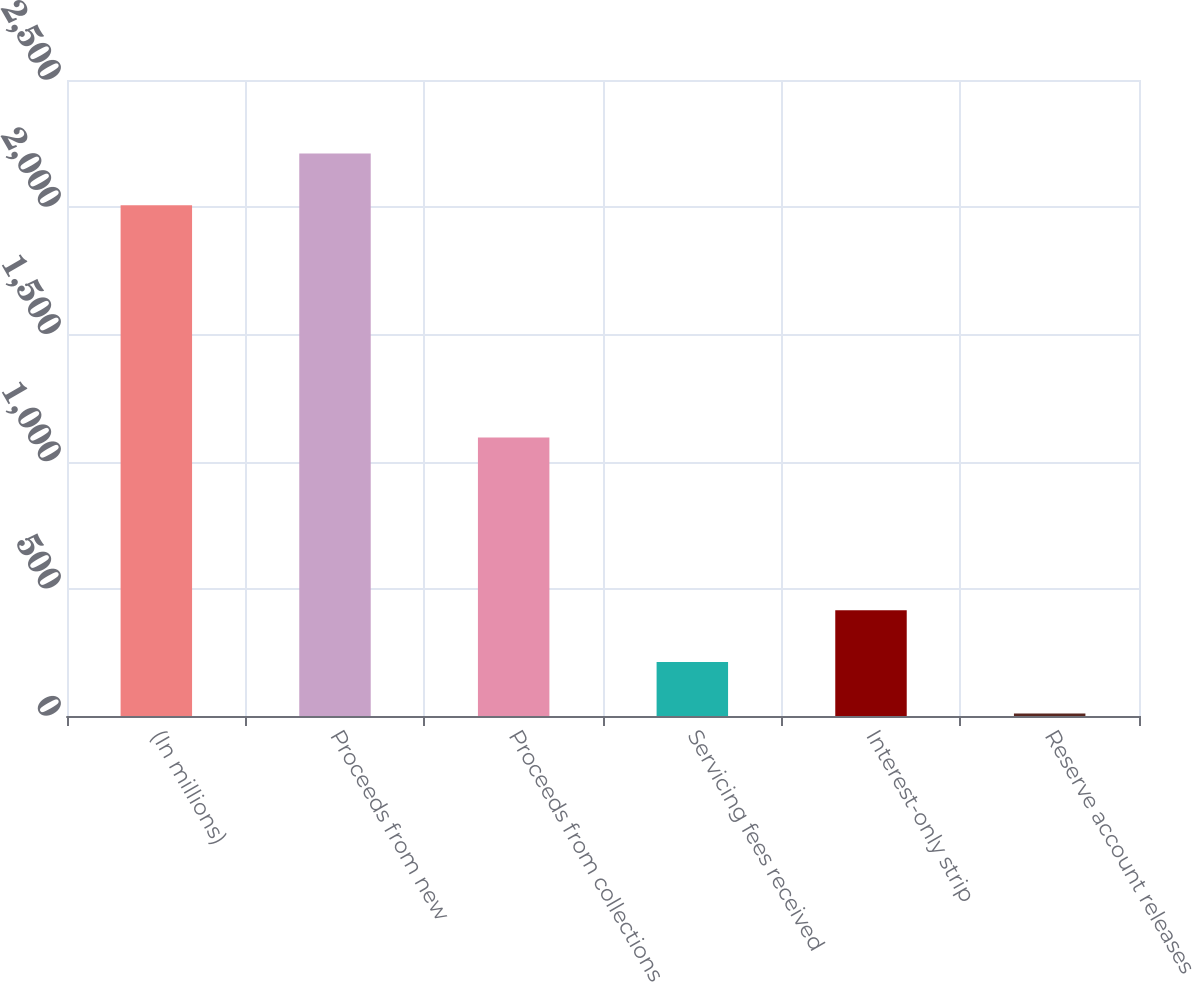Convert chart to OTSL. <chart><loc_0><loc_0><loc_500><loc_500><bar_chart><fcel>(In millions)<fcel>Proceeds from new<fcel>Proceeds from collections<fcel>Servicing fees received<fcel>Interest-only strip<fcel>Reserve account releases<nl><fcel>2008<fcel>2211.08<fcel>1095<fcel>212.48<fcel>415.56<fcel>9.4<nl></chart> 